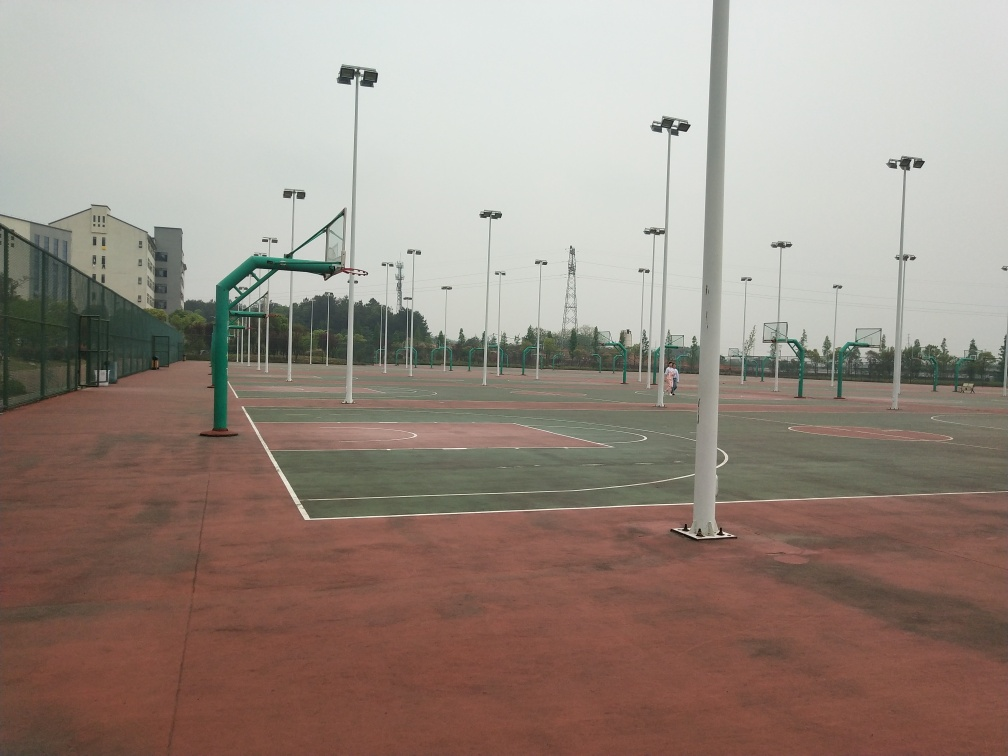Does the layout suggest anything about how the games might be organized here? The layout with multiple courts close to each other implies the facility is capable of supporting multiple games simultaneously, which is ideal for tournaments or sports classes with various groups practicing at the same time. The fencing around each court helps to keep balls within play areas and minimize interference between adjacent games. 